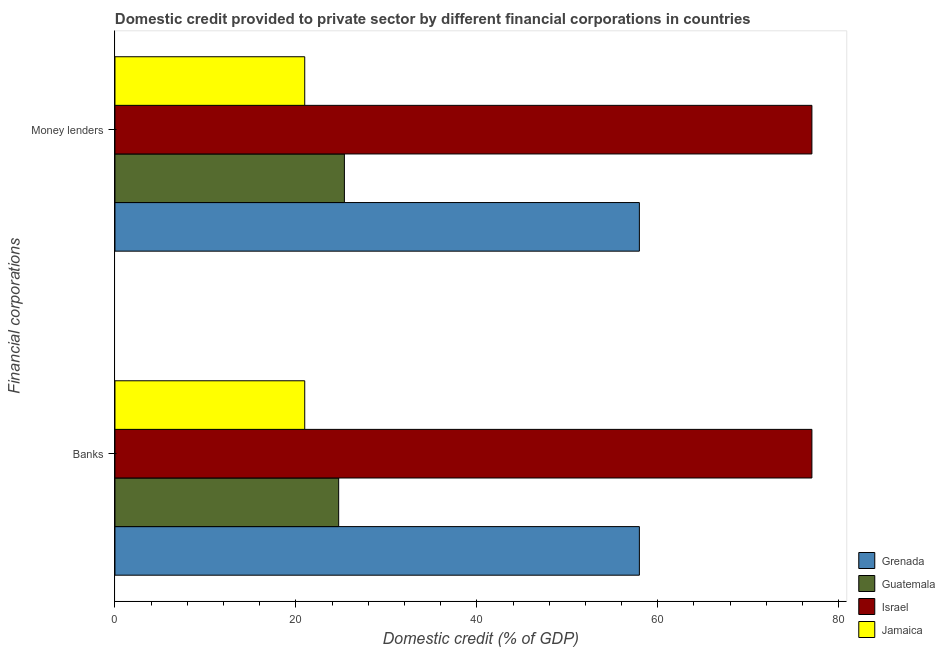How many groups of bars are there?
Provide a short and direct response. 2. What is the label of the 2nd group of bars from the top?
Ensure brevity in your answer.  Banks. What is the domestic credit provided by banks in Guatemala?
Keep it short and to the point. 24.73. Across all countries, what is the maximum domestic credit provided by banks?
Keep it short and to the point. 77.04. Across all countries, what is the minimum domestic credit provided by banks?
Your answer should be very brief. 20.98. In which country was the domestic credit provided by money lenders minimum?
Your answer should be compact. Jamaica. What is the total domestic credit provided by money lenders in the graph?
Your answer should be very brief. 181.34. What is the difference between the domestic credit provided by money lenders in Israel and that in Guatemala?
Offer a terse response. 51.68. What is the difference between the domestic credit provided by banks in Guatemala and the domestic credit provided by money lenders in Grenada?
Provide a short and direct response. -33.24. What is the average domestic credit provided by banks per country?
Provide a short and direct response. 45.18. In how many countries, is the domestic credit provided by money lenders greater than 76 %?
Your response must be concise. 1. What is the ratio of the domestic credit provided by money lenders in Guatemala to that in Jamaica?
Give a very brief answer. 1.21. What does the 2nd bar from the top in Banks represents?
Offer a terse response. Israel. What does the 4th bar from the bottom in Banks represents?
Offer a terse response. Jamaica. Does the graph contain any zero values?
Provide a succinct answer. No. Does the graph contain grids?
Provide a short and direct response. No. How many legend labels are there?
Offer a very short reply. 4. How are the legend labels stacked?
Keep it short and to the point. Vertical. What is the title of the graph?
Give a very brief answer. Domestic credit provided to private sector by different financial corporations in countries. Does "East Asia (developing only)" appear as one of the legend labels in the graph?
Ensure brevity in your answer.  No. What is the label or title of the X-axis?
Provide a short and direct response. Domestic credit (% of GDP). What is the label or title of the Y-axis?
Your answer should be compact. Financial corporations. What is the Domestic credit (% of GDP) in Grenada in Banks?
Your answer should be compact. 57.97. What is the Domestic credit (% of GDP) in Guatemala in Banks?
Keep it short and to the point. 24.73. What is the Domestic credit (% of GDP) in Israel in Banks?
Your answer should be compact. 77.04. What is the Domestic credit (% of GDP) of Jamaica in Banks?
Make the answer very short. 20.98. What is the Domestic credit (% of GDP) of Grenada in Money lenders?
Your response must be concise. 57.97. What is the Domestic credit (% of GDP) in Guatemala in Money lenders?
Provide a succinct answer. 25.36. What is the Domestic credit (% of GDP) of Israel in Money lenders?
Ensure brevity in your answer.  77.04. What is the Domestic credit (% of GDP) of Jamaica in Money lenders?
Your answer should be compact. 20.98. Across all Financial corporations, what is the maximum Domestic credit (% of GDP) in Grenada?
Provide a short and direct response. 57.97. Across all Financial corporations, what is the maximum Domestic credit (% of GDP) of Guatemala?
Your response must be concise. 25.36. Across all Financial corporations, what is the maximum Domestic credit (% of GDP) in Israel?
Keep it short and to the point. 77.04. Across all Financial corporations, what is the maximum Domestic credit (% of GDP) of Jamaica?
Provide a short and direct response. 20.98. Across all Financial corporations, what is the minimum Domestic credit (% of GDP) in Grenada?
Ensure brevity in your answer.  57.97. Across all Financial corporations, what is the minimum Domestic credit (% of GDP) of Guatemala?
Your response must be concise. 24.73. Across all Financial corporations, what is the minimum Domestic credit (% of GDP) in Israel?
Your response must be concise. 77.04. Across all Financial corporations, what is the minimum Domestic credit (% of GDP) of Jamaica?
Offer a terse response. 20.98. What is the total Domestic credit (% of GDP) in Grenada in the graph?
Make the answer very short. 115.93. What is the total Domestic credit (% of GDP) in Guatemala in the graph?
Your answer should be very brief. 50.09. What is the total Domestic credit (% of GDP) in Israel in the graph?
Give a very brief answer. 154.08. What is the total Domestic credit (% of GDP) of Jamaica in the graph?
Keep it short and to the point. 41.96. What is the difference between the Domestic credit (% of GDP) of Guatemala in Banks and that in Money lenders?
Give a very brief answer. -0.63. What is the difference between the Domestic credit (% of GDP) of Grenada in Banks and the Domestic credit (% of GDP) of Guatemala in Money lenders?
Keep it short and to the point. 32.61. What is the difference between the Domestic credit (% of GDP) of Grenada in Banks and the Domestic credit (% of GDP) of Israel in Money lenders?
Ensure brevity in your answer.  -19.07. What is the difference between the Domestic credit (% of GDP) in Grenada in Banks and the Domestic credit (% of GDP) in Jamaica in Money lenders?
Provide a short and direct response. 36.99. What is the difference between the Domestic credit (% of GDP) of Guatemala in Banks and the Domestic credit (% of GDP) of Israel in Money lenders?
Give a very brief answer. -52.31. What is the difference between the Domestic credit (% of GDP) of Guatemala in Banks and the Domestic credit (% of GDP) of Jamaica in Money lenders?
Provide a succinct answer. 3.75. What is the difference between the Domestic credit (% of GDP) of Israel in Banks and the Domestic credit (% of GDP) of Jamaica in Money lenders?
Provide a succinct answer. 56.06. What is the average Domestic credit (% of GDP) in Grenada per Financial corporations?
Offer a very short reply. 57.97. What is the average Domestic credit (% of GDP) in Guatemala per Financial corporations?
Offer a very short reply. 25.04. What is the average Domestic credit (% of GDP) in Israel per Financial corporations?
Your answer should be very brief. 77.04. What is the average Domestic credit (% of GDP) in Jamaica per Financial corporations?
Offer a terse response. 20.98. What is the difference between the Domestic credit (% of GDP) of Grenada and Domestic credit (% of GDP) of Guatemala in Banks?
Offer a very short reply. 33.24. What is the difference between the Domestic credit (% of GDP) of Grenada and Domestic credit (% of GDP) of Israel in Banks?
Ensure brevity in your answer.  -19.07. What is the difference between the Domestic credit (% of GDP) of Grenada and Domestic credit (% of GDP) of Jamaica in Banks?
Ensure brevity in your answer.  36.99. What is the difference between the Domestic credit (% of GDP) of Guatemala and Domestic credit (% of GDP) of Israel in Banks?
Give a very brief answer. -52.31. What is the difference between the Domestic credit (% of GDP) of Guatemala and Domestic credit (% of GDP) of Jamaica in Banks?
Provide a succinct answer. 3.75. What is the difference between the Domestic credit (% of GDP) of Israel and Domestic credit (% of GDP) of Jamaica in Banks?
Keep it short and to the point. 56.06. What is the difference between the Domestic credit (% of GDP) in Grenada and Domestic credit (% of GDP) in Guatemala in Money lenders?
Your response must be concise. 32.61. What is the difference between the Domestic credit (% of GDP) in Grenada and Domestic credit (% of GDP) in Israel in Money lenders?
Offer a terse response. -19.07. What is the difference between the Domestic credit (% of GDP) in Grenada and Domestic credit (% of GDP) in Jamaica in Money lenders?
Ensure brevity in your answer.  36.99. What is the difference between the Domestic credit (% of GDP) of Guatemala and Domestic credit (% of GDP) of Israel in Money lenders?
Offer a terse response. -51.68. What is the difference between the Domestic credit (% of GDP) in Guatemala and Domestic credit (% of GDP) in Jamaica in Money lenders?
Give a very brief answer. 4.38. What is the difference between the Domestic credit (% of GDP) in Israel and Domestic credit (% of GDP) in Jamaica in Money lenders?
Ensure brevity in your answer.  56.06. What is the ratio of the Domestic credit (% of GDP) in Israel in Banks to that in Money lenders?
Give a very brief answer. 1. What is the difference between the highest and the second highest Domestic credit (% of GDP) of Guatemala?
Your response must be concise. 0.63. What is the difference between the highest and the lowest Domestic credit (% of GDP) in Guatemala?
Keep it short and to the point. 0.63. What is the difference between the highest and the lowest Domestic credit (% of GDP) of Israel?
Ensure brevity in your answer.  0. 